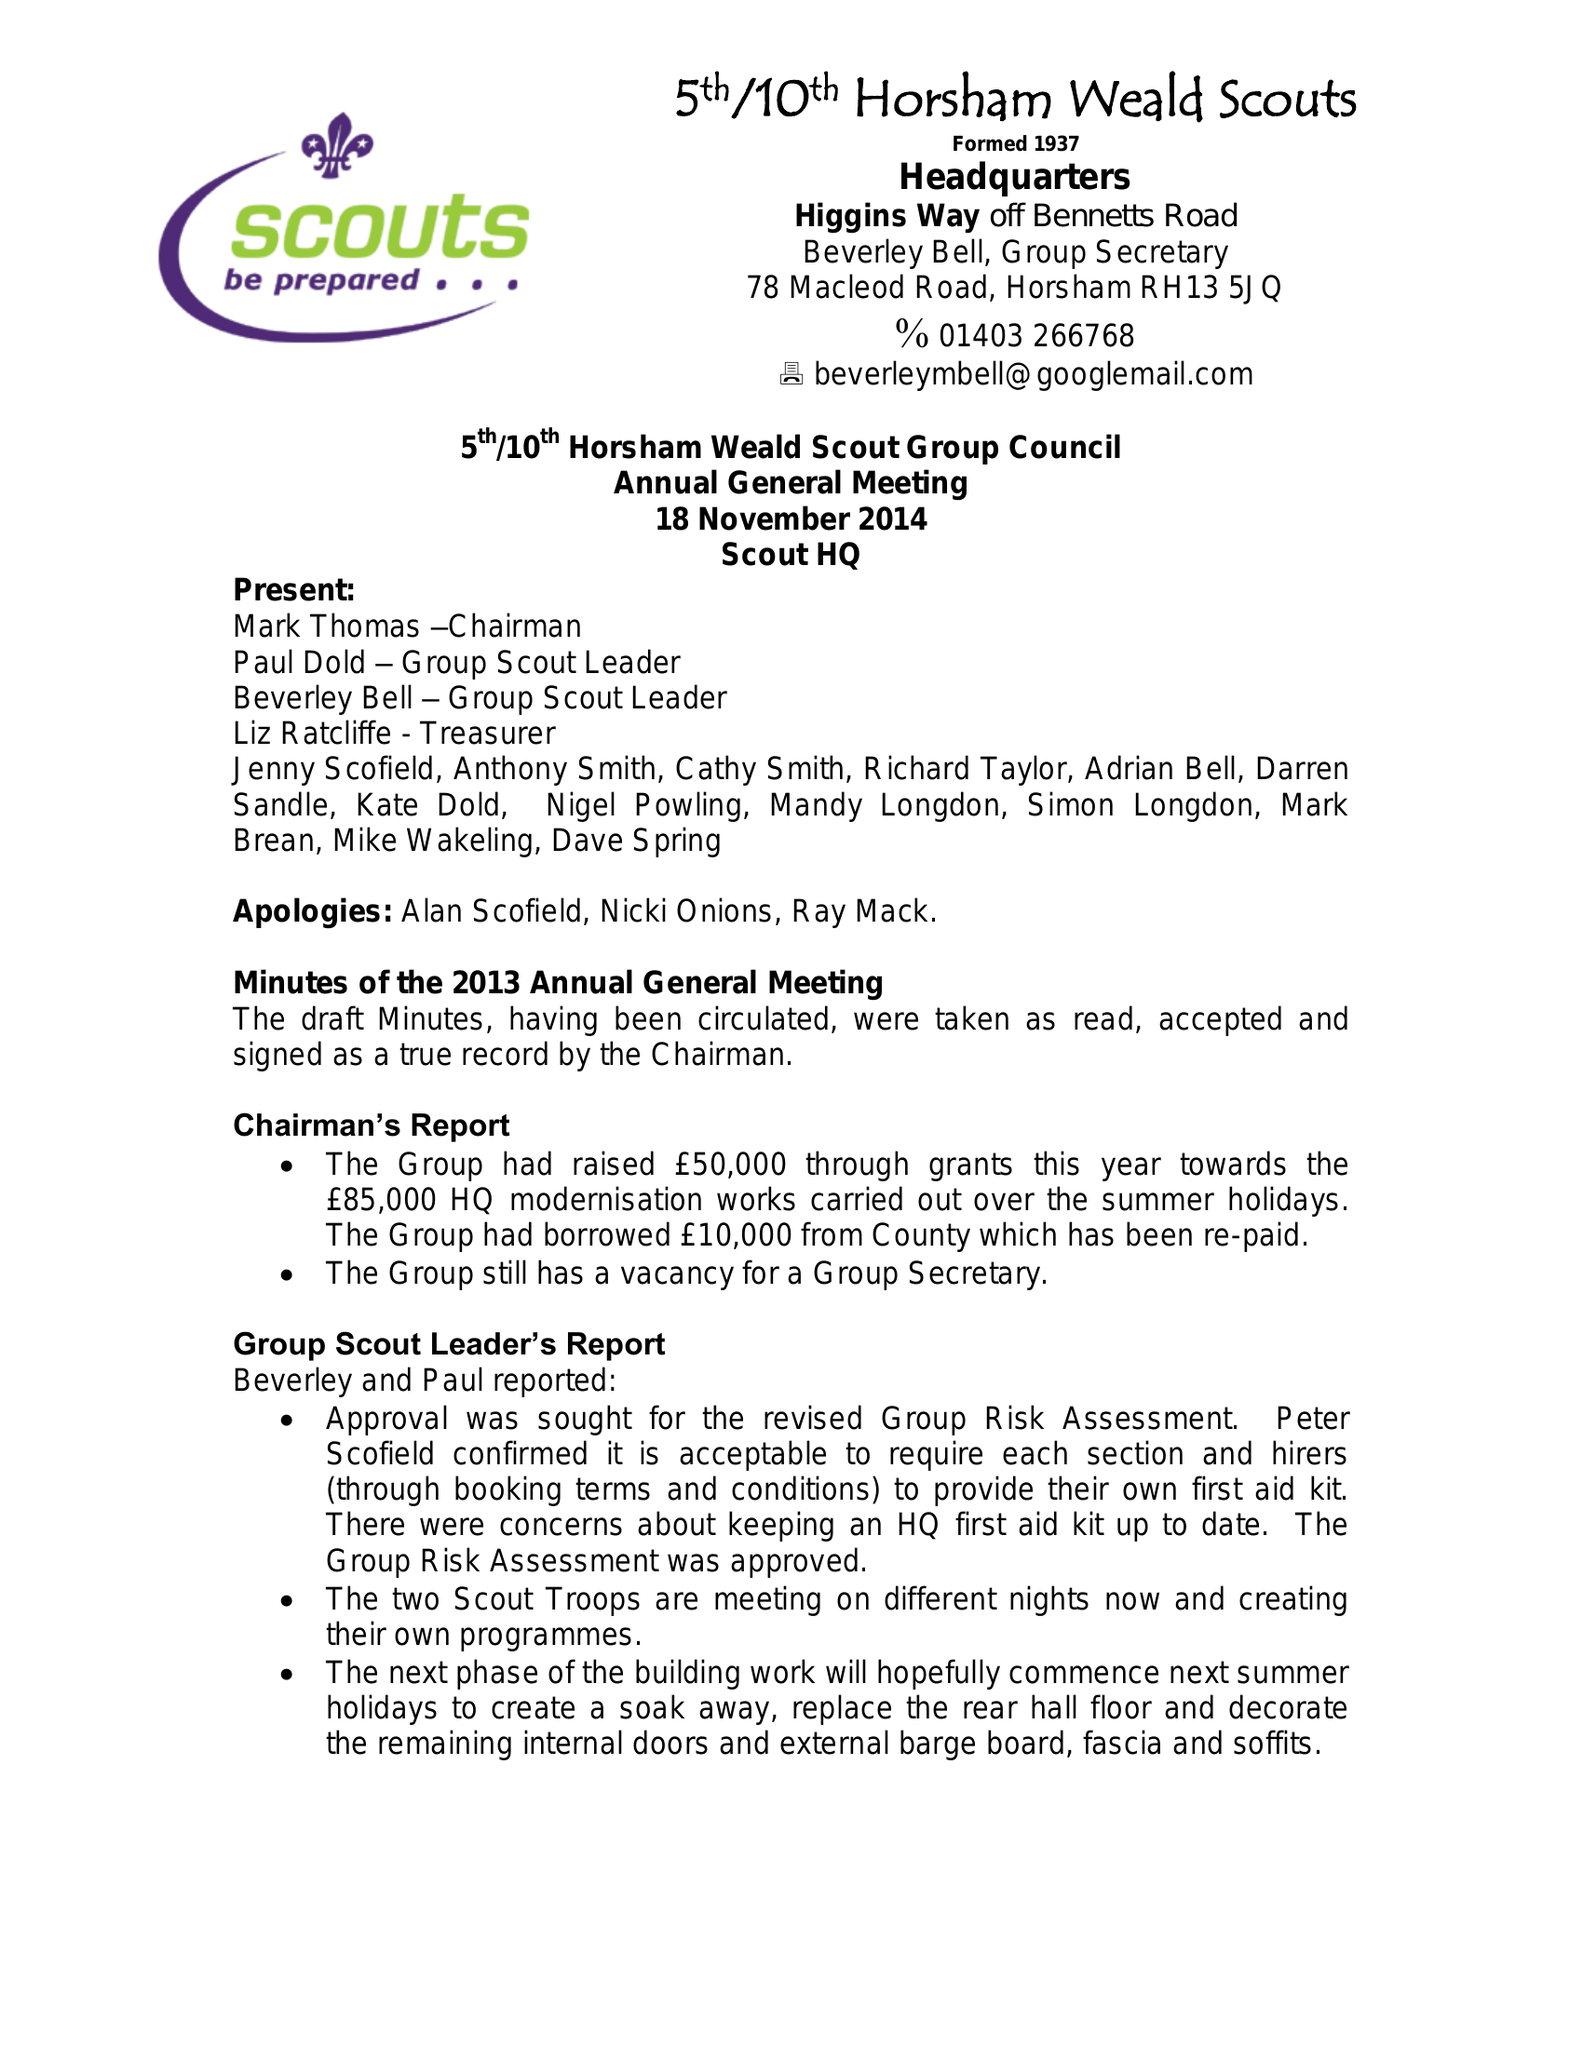What is the value for the address__postcode?
Answer the question using a single word or phrase. RH13 5EF 